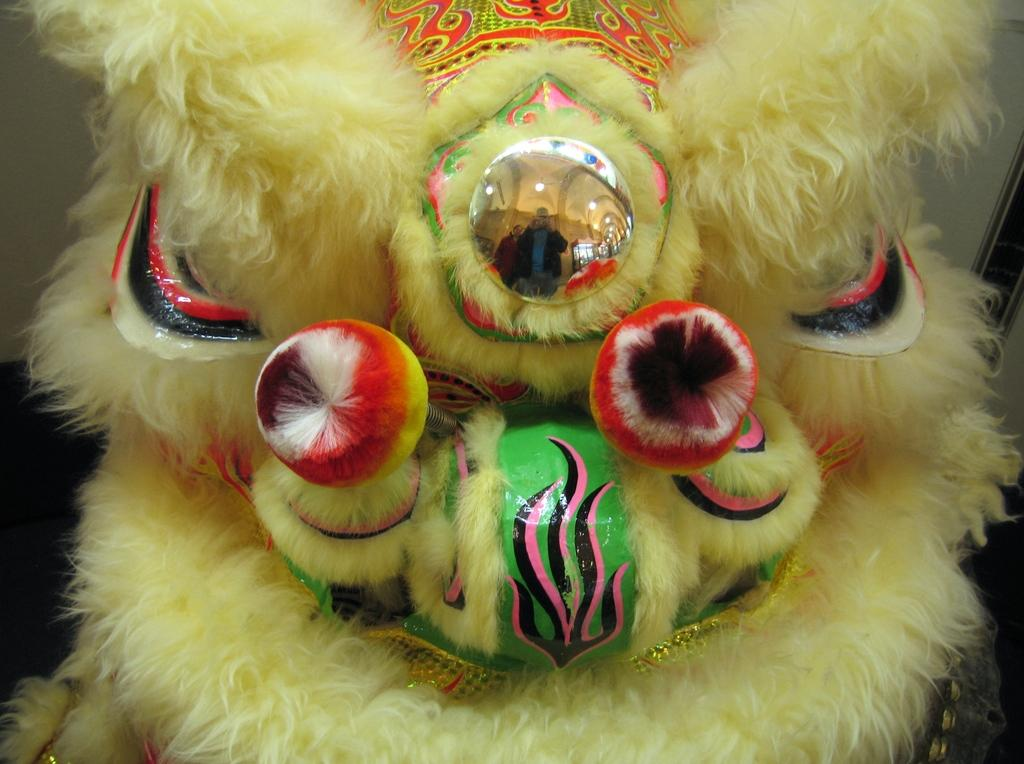What object is present in the picture? There is a toy in the picture. What can be seen in the reflection of the toy? The reflection of two people and a building can be seen in the toy. What is visible at the back of the picture? There is a wall visible at the back of the picture. What type of underwear is visible in the reflection of the toy? There is no underwear visible in the reflection of the toy; it only shows the reflection of two people and a building. What type of glass is used to make the toy? The type of glass used to make the toy is not mentioned in the image, and therefore cannot be determined. 